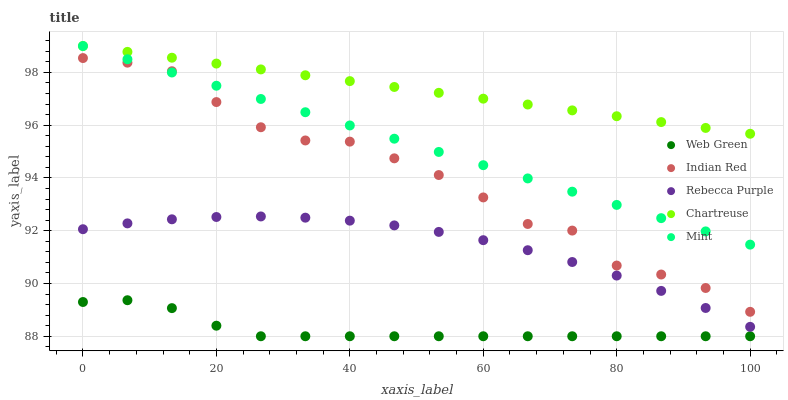Does Web Green have the minimum area under the curve?
Answer yes or no. Yes. Does Chartreuse have the maximum area under the curve?
Answer yes or no. Yes. Does Mint have the minimum area under the curve?
Answer yes or no. No. Does Mint have the maximum area under the curve?
Answer yes or no. No. Is Mint the smoothest?
Answer yes or no. Yes. Is Indian Red the roughest?
Answer yes or no. Yes. Is Indian Red the smoothest?
Answer yes or no. No. Is Mint the roughest?
Answer yes or no. No. Does Web Green have the lowest value?
Answer yes or no. Yes. Does Mint have the lowest value?
Answer yes or no. No. Does Mint have the highest value?
Answer yes or no. Yes. Does Indian Red have the highest value?
Answer yes or no. No. Is Rebecca Purple less than Chartreuse?
Answer yes or no. Yes. Is Mint greater than Web Green?
Answer yes or no. Yes. Does Indian Red intersect Mint?
Answer yes or no. Yes. Is Indian Red less than Mint?
Answer yes or no. No. Is Indian Red greater than Mint?
Answer yes or no. No. Does Rebecca Purple intersect Chartreuse?
Answer yes or no. No. 